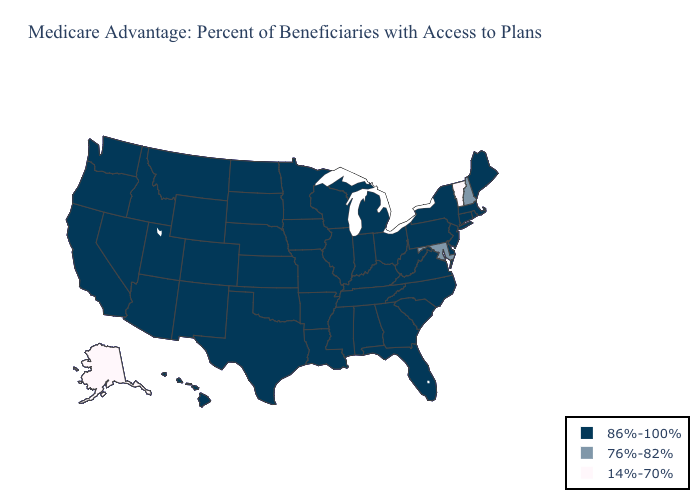What is the value of Mississippi?
Write a very short answer. 86%-100%. Name the states that have a value in the range 86%-100%?
Give a very brief answer. Alabama, Arkansas, Arizona, California, Colorado, Connecticut, Delaware, Florida, Georgia, Hawaii, Iowa, Idaho, Illinois, Indiana, Kansas, Kentucky, Louisiana, Massachusetts, Maine, Michigan, Minnesota, Missouri, Mississippi, Montana, North Carolina, North Dakota, Nebraska, New Jersey, New Mexico, Nevada, New York, Ohio, Oklahoma, Oregon, Pennsylvania, Rhode Island, South Carolina, South Dakota, Tennessee, Texas, Utah, Virginia, Washington, Wisconsin, West Virginia, Wyoming. Which states hav the highest value in the South?
Keep it brief. Alabama, Arkansas, Delaware, Florida, Georgia, Kentucky, Louisiana, Mississippi, North Carolina, Oklahoma, South Carolina, Tennessee, Texas, Virginia, West Virginia. What is the lowest value in the South?
Concise answer only. 76%-82%. What is the highest value in the USA?
Keep it brief. 86%-100%. Name the states that have a value in the range 14%-70%?
Quick response, please. Alaska, Vermont. Name the states that have a value in the range 14%-70%?
Keep it brief. Alaska, Vermont. What is the lowest value in the USA?
Short answer required. 14%-70%. Name the states that have a value in the range 86%-100%?
Answer briefly. Alabama, Arkansas, Arizona, California, Colorado, Connecticut, Delaware, Florida, Georgia, Hawaii, Iowa, Idaho, Illinois, Indiana, Kansas, Kentucky, Louisiana, Massachusetts, Maine, Michigan, Minnesota, Missouri, Mississippi, Montana, North Carolina, North Dakota, Nebraska, New Jersey, New Mexico, Nevada, New York, Ohio, Oklahoma, Oregon, Pennsylvania, Rhode Island, South Carolina, South Dakota, Tennessee, Texas, Utah, Virginia, Washington, Wisconsin, West Virginia, Wyoming. Name the states that have a value in the range 86%-100%?
Answer briefly. Alabama, Arkansas, Arizona, California, Colorado, Connecticut, Delaware, Florida, Georgia, Hawaii, Iowa, Idaho, Illinois, Indiana, Kansas, Kentucky, Louisiana, Massachusetts, Maine, Michigan, Minnesota, Missouri, Mississippi, Montana, North Carolina, North Dakota, Nebraska, New Jersey, New Mexico, Nevada, New York, Ohio, Oklahoma, Oregon, Pennsylvania, Rhode Island, South Carolina, South Dakota, Tennessee, Texas, Utah, Virginia, Washington, Wisconsin, West Virginia, Wyoming. What is the lowest value in the South?
Give a very brief answer. 76%-82%. Name the states that have a value in the range 76%-82%?
Concise answer only. Maryland, New Hampshire. Does Indiana have the highest value in the USA?
Write a very short answer. Yes. What is the value of Oklahoma?
Answer briefly. 86%-100%. 